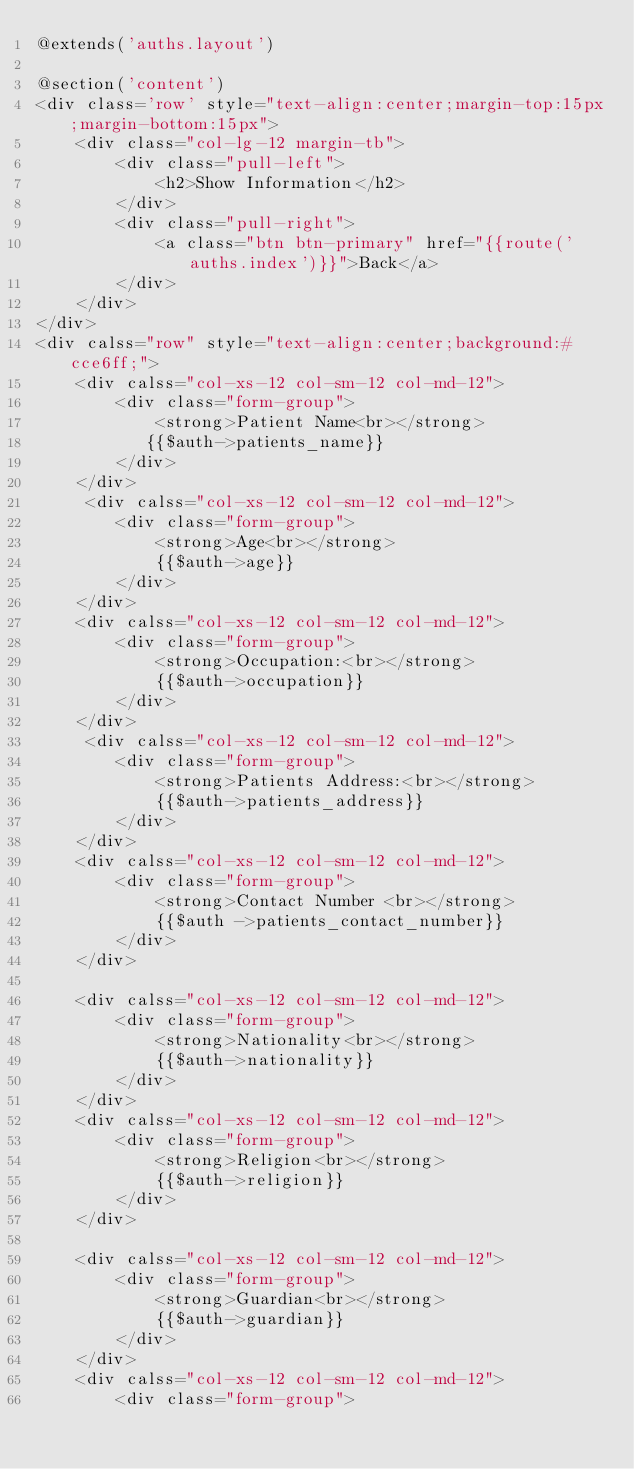Convert code to text. <code><loc_0><loc_0><loc_500><loc_500><_PHP_>@extends('auths.layout')

@section('content')
<div class='row' style="text-align:center;margin-top:15px;margin-bottom:15px">
    <div class="col-lg-12 margin-tb">
        <div class="pull-left">
            <h2>Show Information</h2>
        </div>
        <div class="pull-right">
            <a class="btn btn-primary" href="{{route('auths.index')}}">Back</a>
        </div>
    </div>
</div>
<div calss="row" style="text-align:center;background:#cce6ff;"> 
    <div calss="col-xs-12 col-sm-12 col-md-12">
        <div class="form-group">
            <strong>Patient Name<br></strong>
           {{$auth->patients_name}}
        </div>
    </div>
     <div calss="col-xs-12 col-sm-12 col-md-12">
        <div class="form-group">
            <strong>Age<br></strong>
            {{$auth->age}}
        </div>
    </div>
    <div calss="col-xs-12 col-sm-12 col-md-12">
        <div class="form-group">
            <strong>Occupation:<br></strong>
            {{$auth->occupation}}
        </div>
    </div>
     <div calss="col-xs-12 col-sm-12 col-md-12">
        <div class="form-group">
            <strong>Patients Address:<br></strong>
            {{$auth->patients_address}}
        </div>
    </div>
    <div calss="col-xs-12 col-sm-12 col-md-12">
        <div class="form-group">
            <strong>Contact Number <br></strong>
            {{$auth ->patients_contact_number}}
        </div>
    </div>
   
    <div calss="col-xs-12 col-sm-12 col-md-12">
        <div class="form-group">
            <strong>Nationality<br></strong>
            {{$auth->nationality}}
        </div>
    </div>
    <div calss="col-xs-12 col-sm-12 col-md-12">
        <div class="form-group">
            <strong>Religion<br></strong>
            {{$auth->religion}}
        </div>
    </div>
    
    <div calss="col-xs-12 col-sm-12 col-md-12">
        <div class="form-group">
            <strong>Guardian<br></strong>
            {{$auth->guardian}}
        </div>
    </div>
    <div calss="col-xs-12 col-sm-12 col-md-12">
        <div class="form-group"></code> 